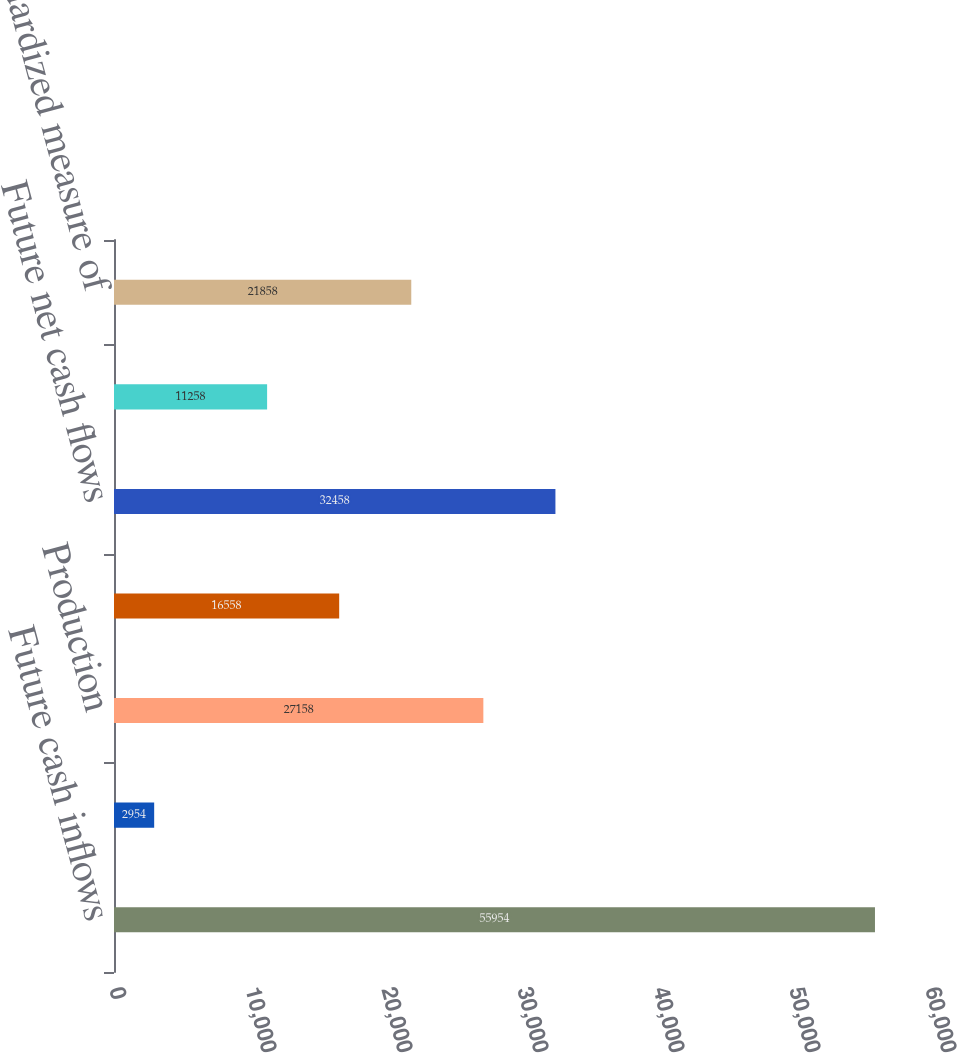<chart> <loc_0><loc_0><loc_500><loc_500><bar_chart><fcel>Future cash inflows<fcel>Development<fcel>Production<fcel>Future income tax expense<fcel>Future net cash flows<fcel>10 discount to reflect timing<fcel>Standardized measure of<nl><fcel>55954<fcel>2954<fcel>27158<fcel>16558<fcel>32458<fcel>11258<fcel>21858<nl></chart> 